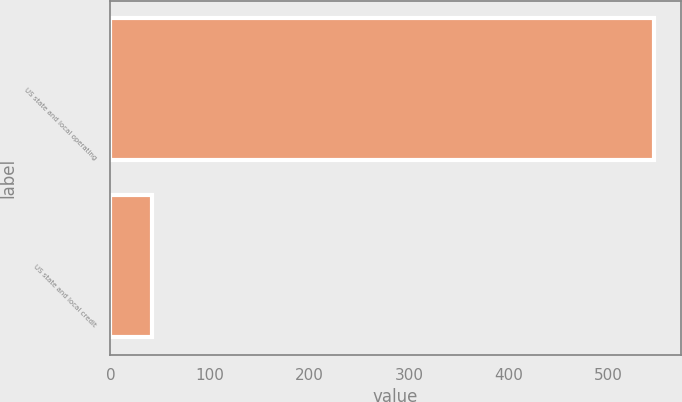Convert chart to OTSL. <chart><loc_0><loc_0><loc_500><loc_500><bar_chart><fcel>US state and local operating<fcel>US state and local credit<nl><fcel>546<fcel>42<nl></chart> 